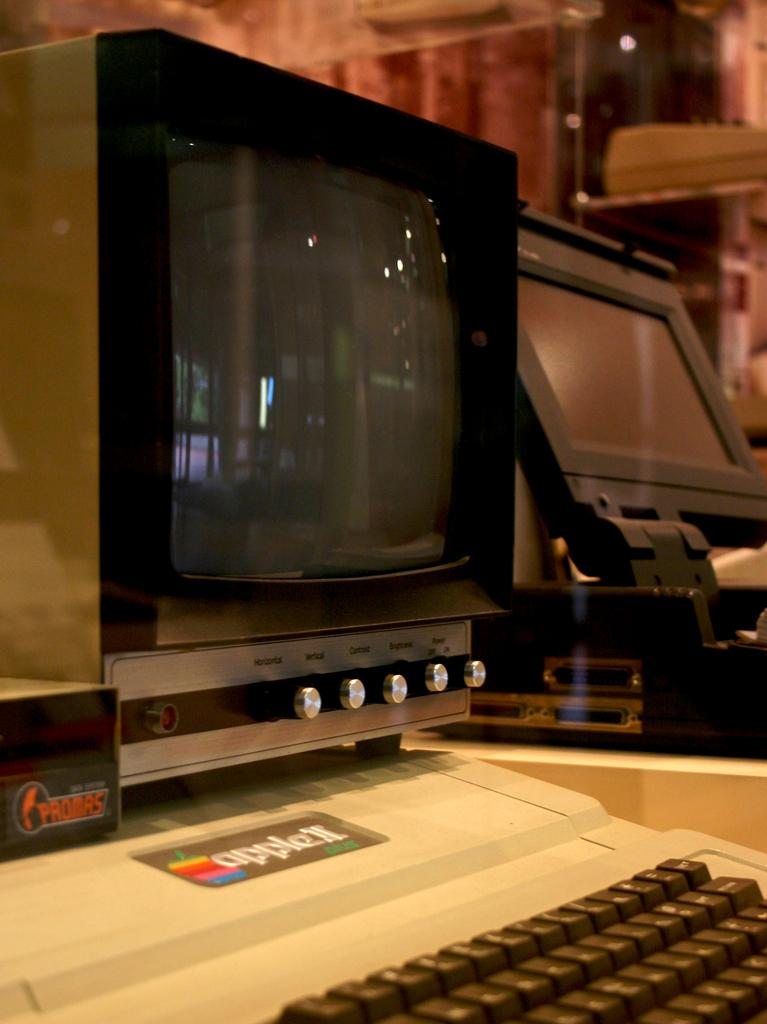What electronic device is the main subject of the image? There is a television in the image. What object is placed in front of the television? There is a typewriter in front of the television. What other device can be seen beside the television? There is another device beside the television. How many cats are sitting on the typewriter in the image? There are no cats present in the image. What type of fish can be seen swimming in the background of the image? There is no fish visible in the image; it features a television, typewriter, and another device. 